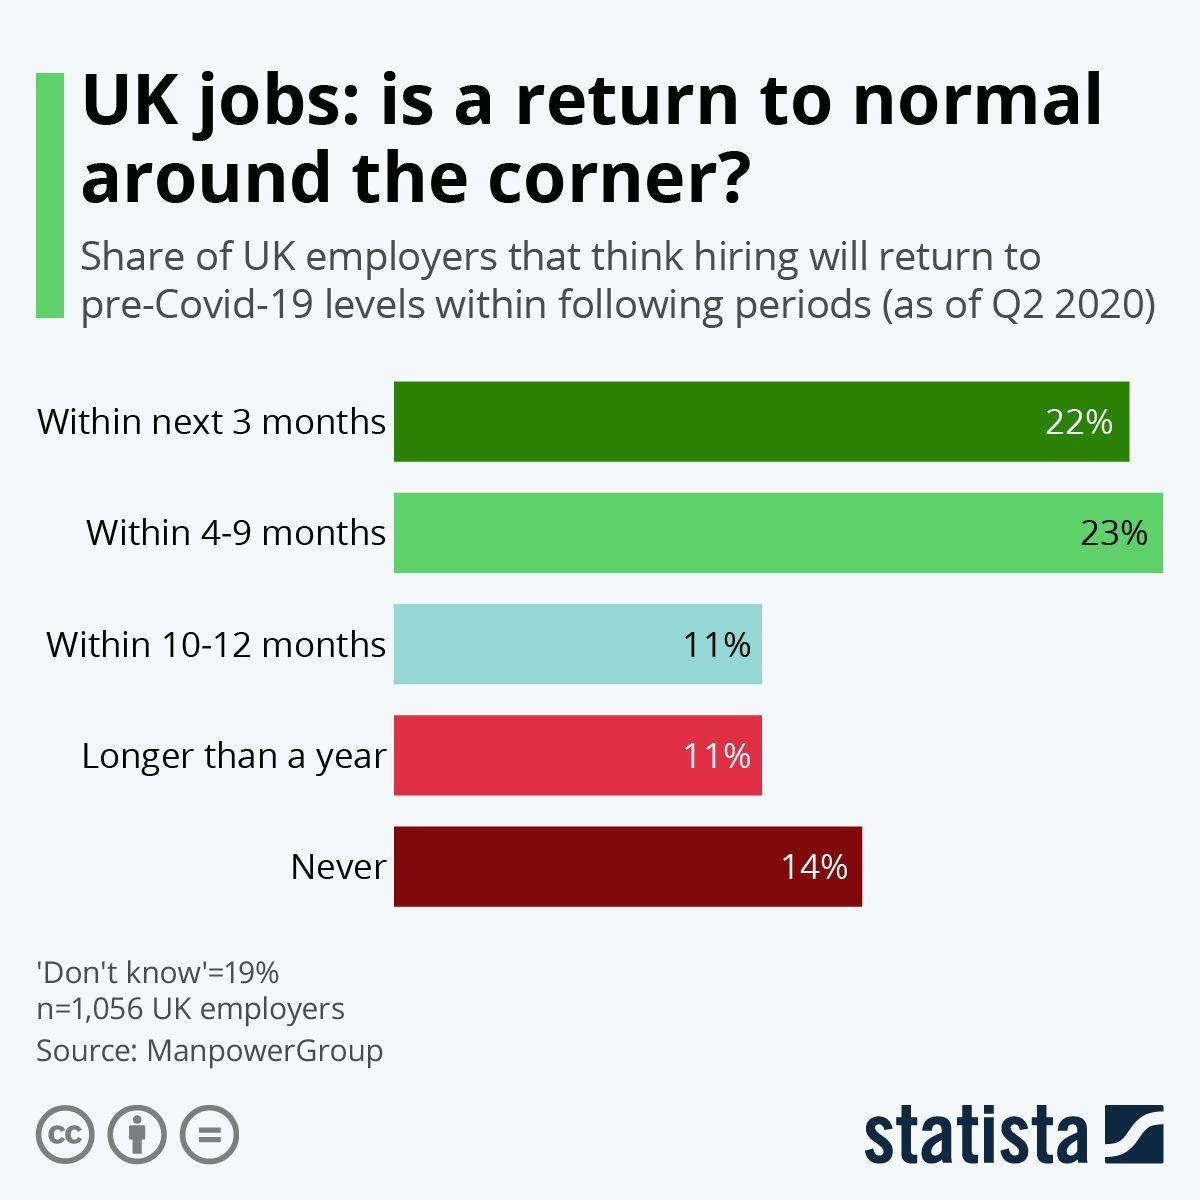What percentage of UK employers think that hiring will return to pre-Covid-19 levels within next 3 months as of Q2 2020?
Answer the question with a short phrase. 22% What percentage of UK employers think that hiring will never return to pre-Covid-19 levels as of Q2 2020? 14% What percentage of UK employers think that hiring will return to pre-Covid-19 levels within 10-12 months as of Q2 2020? 11% What percentage of UK employers think that hiring will return to pre-Covid-19 levels  within 4-9 months as of Q2 2020? 23% 